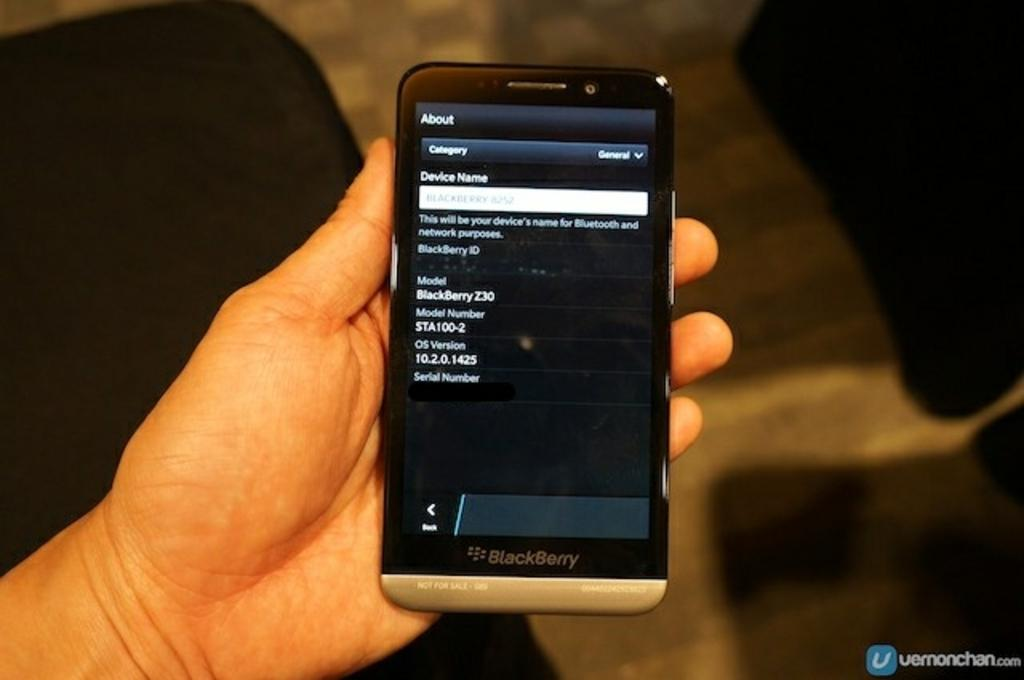<image>
Summarize the visual content of the image. a phone that is showing the about section on it 